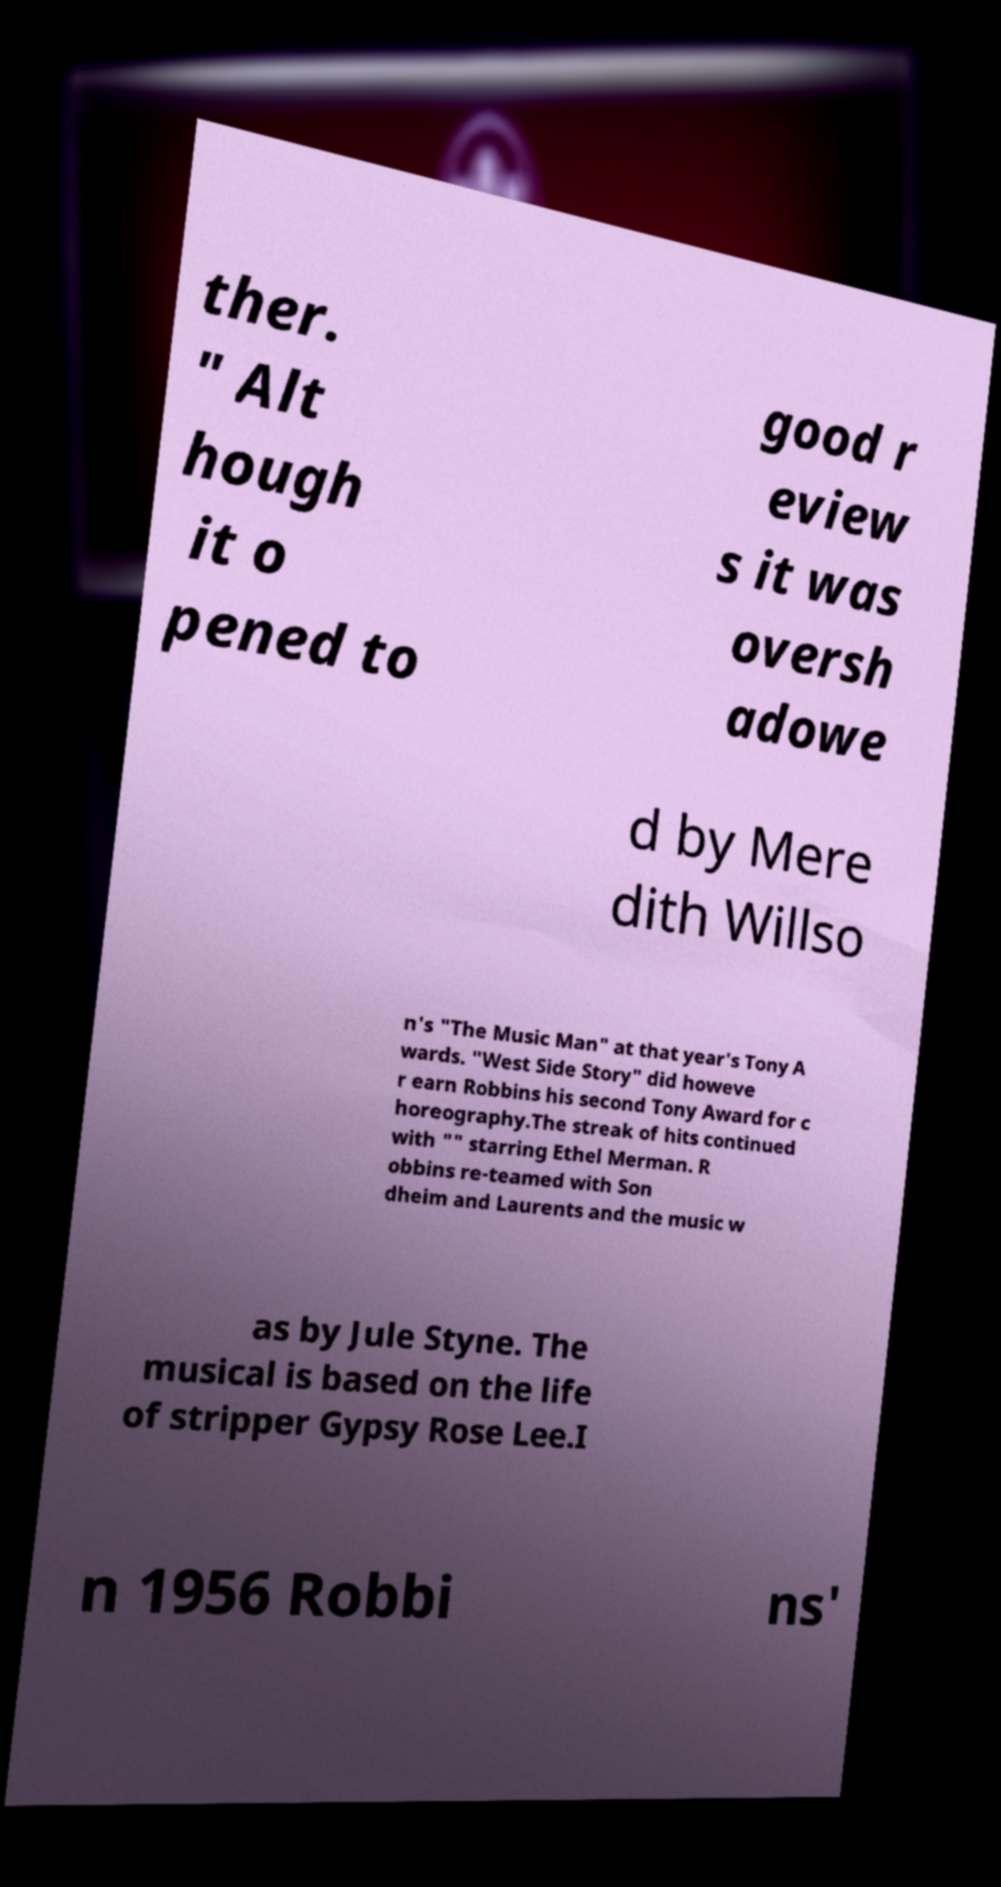Can you read and provide the text displayed in the image?This photo seems to have some interesting text. Can you extract and type it out for me? ther. " Alt hough it o pened to good r eview s it was oversh adowe d by Mere dith Willso n's "The Music Man" at that year's Tony A wards. "West Side Story" did howeve r earn Robbins his second Tony Award for c horeography.The streak of hits continued with "" starring Ethel Merman. R obbins re-teamed with Son dheim and Laurents and the music w as by Jule Styne. The musical is based on the life of stripper Gypsy Rose Lee.I n 1956 Robbi ns' 